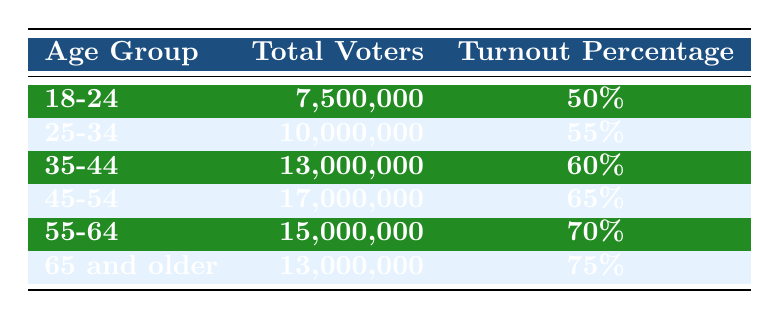What is the turnout percentage for the age group 45-54? From the table, the turnout percentage for the age group 45-54 is listed explicitly. It reads "Turnout Percentage" and shows a bolded value next to that age group.
Answer: 65% Which age group had the highest turnout percentage? The table lists all age groups along with their corresponding turnout percentages. By comparing these percentages, the age group "65 and older" shows the highest at 75%.
Answer: 65 and older How many total voters are there in the age group 55-64? The table directly provides the number of total voters for each age group. For the age group 55-64, it states there are 15,000,000 total voters.
Answer: 15,000,000 What is the total voter count for all age groups combined? To find the total voter count, we add the total voters for each age group: 7,500,000 + 10,000,000 + 13,000,000 + 17,000,000 + 15,000,000 + 13,000,000 = 75,500,000.
Answer: 75,500,000 What is the difference in turnout percentage between the age groups 18-24 and 45-54? The turnout percentage for 18-24 is 50%, and for 45-54 it is 65%. The difference is calculated by subtracting the two percentages: 65% - 50% = 15%.
Answer: 15% Is the turnout percentage for the 25-34 age group higher than that for the 35-44 age group? The table shows that the turnout percentage for the 25-34 age group is 55% and for the 35-44 age group it is 60%. Since 55% is less than 60%, the statement is false.
Answer: No What is the average turnout percentage across all age groups? To find the average, sum all the turnout percentages: 50% + 55% + 60% + 65% + 70% + 75% = 375%. Then, divide by the number of age groups (6): 375% / 6 = 62.5%.
Answer: 62.5% If the age group 65 and older had 13,000,000 total voters, how many more voters does the 45-54 age group have? The total voters for the 45-54 age group is 17,000,000. To find the difference: 17,000,000 - 13,000,000 = 4,000,000.
Answer: 4,000,000 Which age group has the lowest voter turnout percentage? By reviewing the table, the age group 18-24 has the lowest turnout percentage at 50%.
Answer: 18-24 